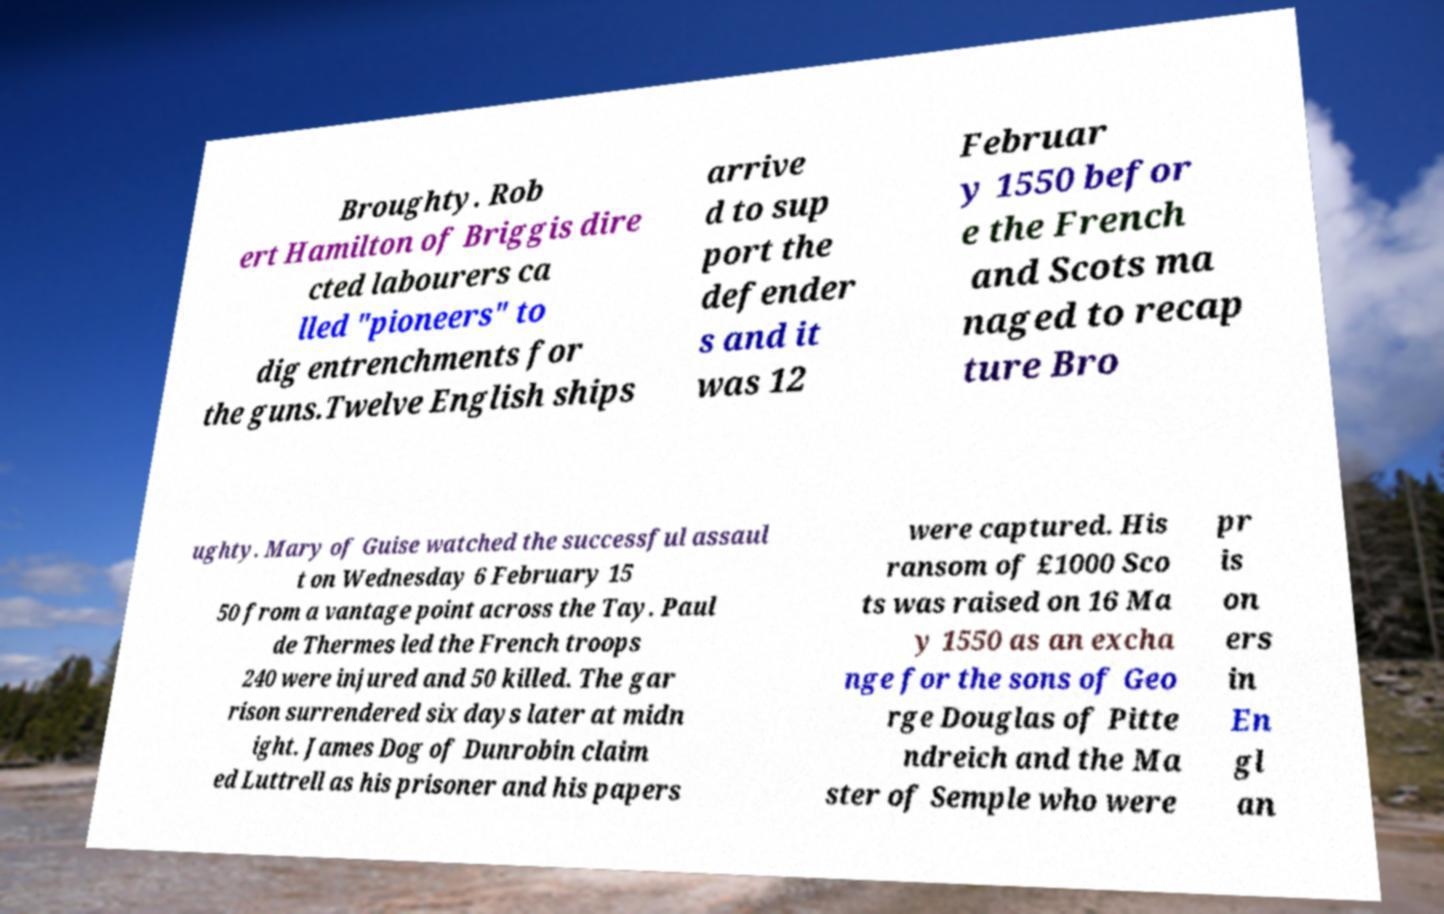I need the written content from this picture converted into text. Can you do that? Broughty. Rob ert Hamilton of Briggis dire cted labourers ca lled "pioneers" to dig entrenchments for the guns.Twelve English ships arrive d to sup port the defender s and it was 12 Februar y 1550 befor e the French and Scots ma naged to recap ture Bro ughty. Mary of Guise watched the successful assaul t on Wednesday 6 February 15 50 from a vantage point across the Tay. Paul de Thermes led the French troops 240 were injured and 50 killed. The gar rison surrendered six days later at midn ight. James Dog of Dunrobin claim ed Luttrell as his prisoner and his papers were captured. His ransom of £1000 Sco ts was raised on 16 Ma y 1550 as an excha nge for the sons of Geo rge Douglas of Pitte ndreich and the Ma ster of Semple who were pr is on ers in En gl an 